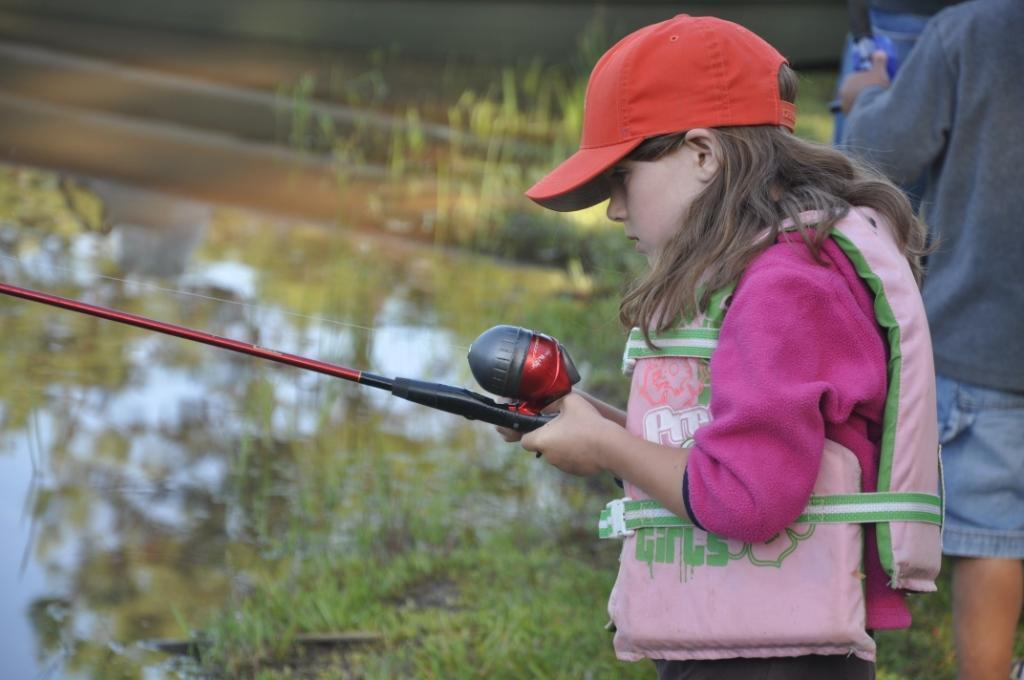Who is present in the image? There is a girl and a man in the image. What is the girl holding in the image? The girl is holding a fishing stick in the image. Where is the man located in the image? The man is on the right side of the image. What type of environment is visible in the image? There is water and grass visible in the image. How much salt is present in the water in the image? There is no information about the salt content in the water in the image. 